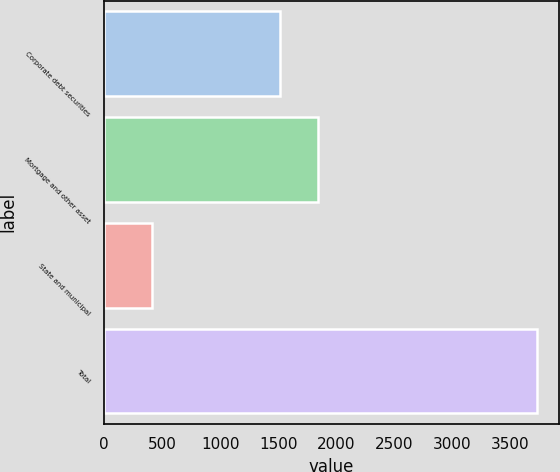<chart> <loc_0><loc_0><loc_500><loc_500><bar_chart><fcel>Corporate debt securities<fcel>Mortgage and other asset<fcel>State and municipal<fcel>Total<nl><fcel>1514<fcel>1845.7<fcel>414<fcel>3731<nl></chart> 